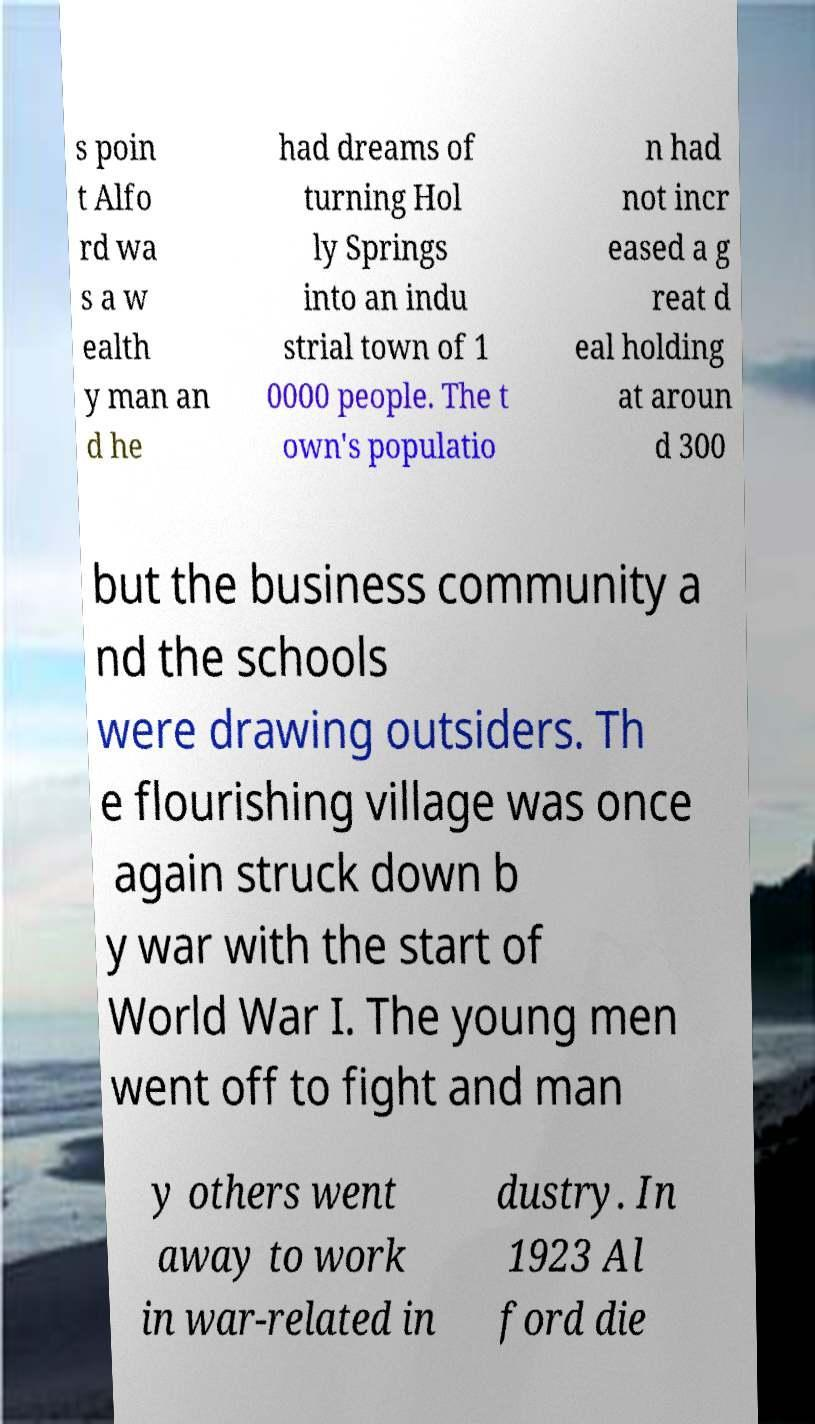What messages or text are displayed in this image? I need them in a readable, typed format. s poin t Alfo rd wa s a w ealth y man an d he had dreams of turning Hol ly Springs into an indu strial town of 1 0000 people. The t own's populatio n had not incr eased a g reat d eal holding at aroun d 300 but the business community a nd the schools were drawing outsiders. Th e flourishing village was once again struck down b y war with the start of World War I. The young men went off to fight and man y others went away to work in war-related in dustry. In 1923 Al ford die 